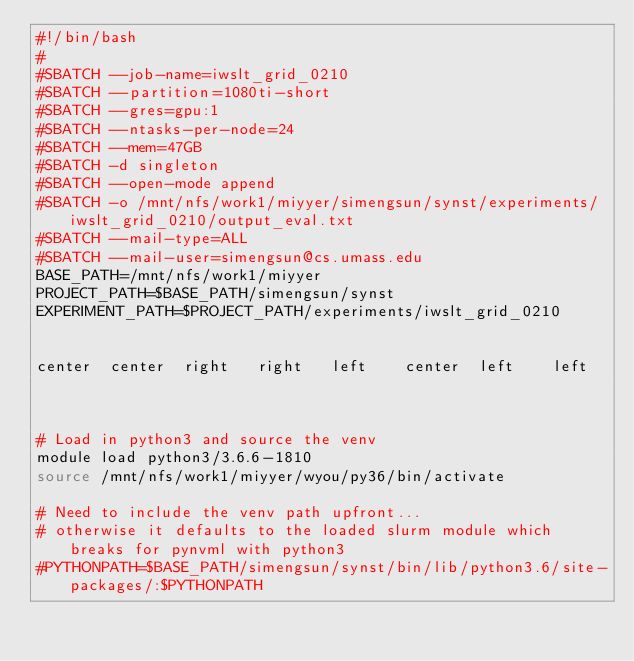<code> <loc_0><loc_0><loc_500><loc_500><_Bash_>#!/bin/bash
#
#SBATCH --job-name=iwslt_grid_0210
#SBATCH --partition=1080ti-short
#SBATCH --gres=gpu:1
#SBATCH --ntasks-per-node=24
#SBATCH --mem=47GB
#SBATCH -d singleton
#SBATCH --open-mode append
#SBATCH -o /mnt/nfs/work1/miyyer/simengsun/synst/experiments/iwslt_grid_0210/output_eval.txt
#SBATCH --mail-type=ALL
#SBATCH --mail-user=simengsun@cs.umass.edu
BASE_PATH=/mnt/nfs/work1/miyyer
PROJECT_PATH=$BASE_PATH/simengsun/synst
EXPERIMENT_PATH=$PROJECT_PATH/experiments/iwslt_grid_0210

	
center	center	right	right	left	center	left	left	


# Load in python3 and source the venv
module load python3/3.6.6-1810
source /mnt/nfs/work1/miyyer/wyou/py36/bin/activate

# Need to include the venv path upfront...
# otherwise it defaults to the loaded slurm module which breaks for pynvml with python3
#PYTHONPATH=$BASE_PATH/simengsun/synst/bin/lib/python3.6/site-packages/:$PYTHONPATH</code> 